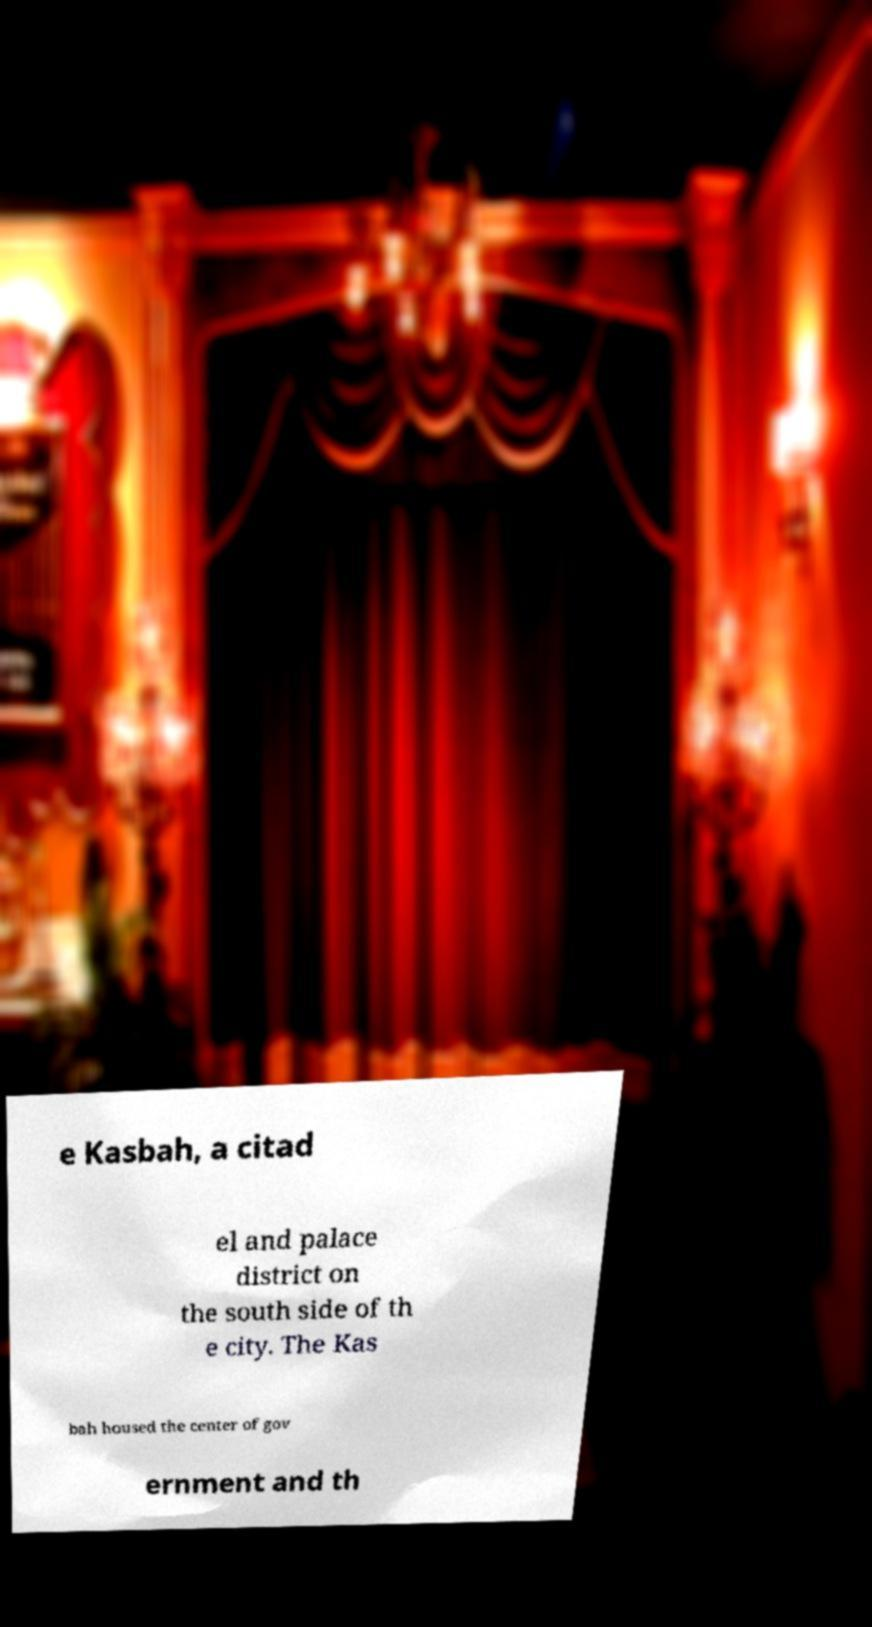I need the written content from this picture converted into text. Can you do that? e Kasbah, a citad el and palace district on the south side of th e city. The Kas bah housed the center of gov ernment and th 